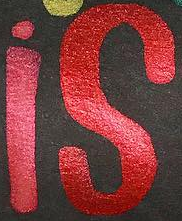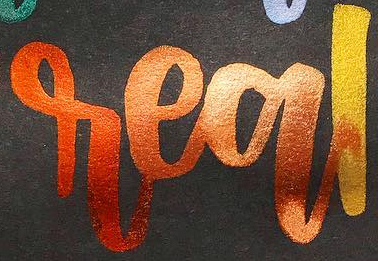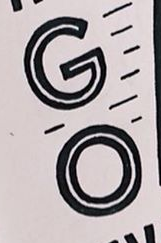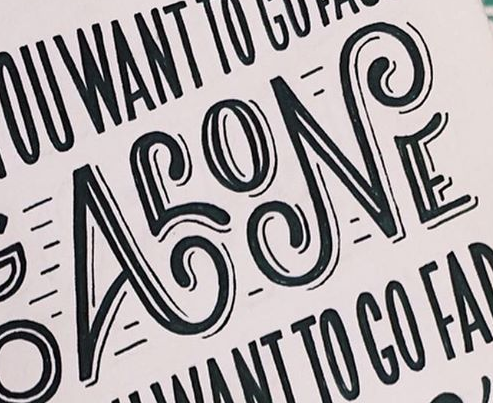Identify the words shown in these images in order, separated by a semicolon. is; real; GO; ALONE 